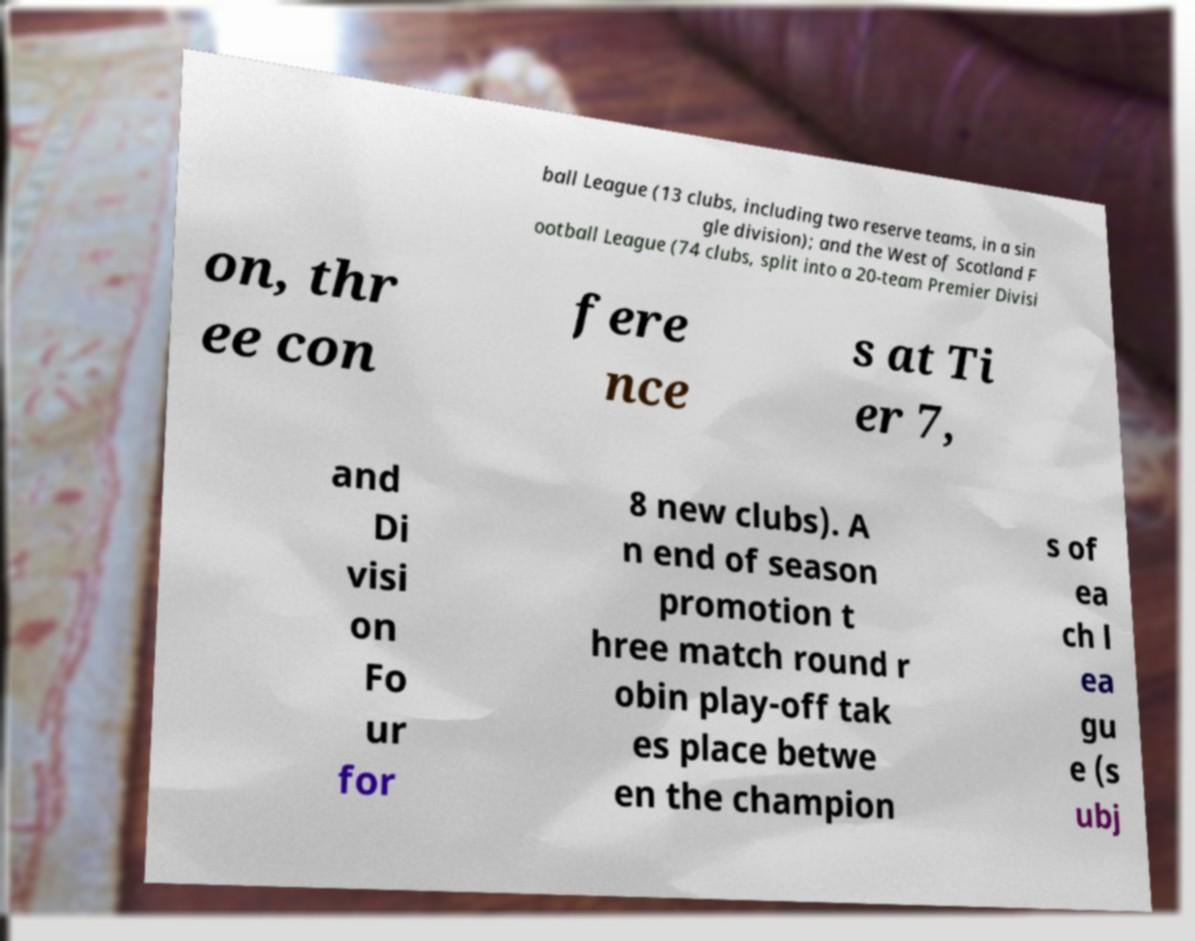There's text embedded in this image that I need extracted. Can you transcribe it verbatim? ball League (13 clubs, including two reserve teams, in a sin gle division); and the West of Scotland F ootball League (74 clubs, split into a 20-team Premier Divisi on, thr ee con fere nce s at Ti er 7, and Di visi on Fo ur for 8 new clubs). A n end of season promotion t hree match round r obin play-off tak es place betwe en the champion s of ea ch l ea gu e (s ubj 